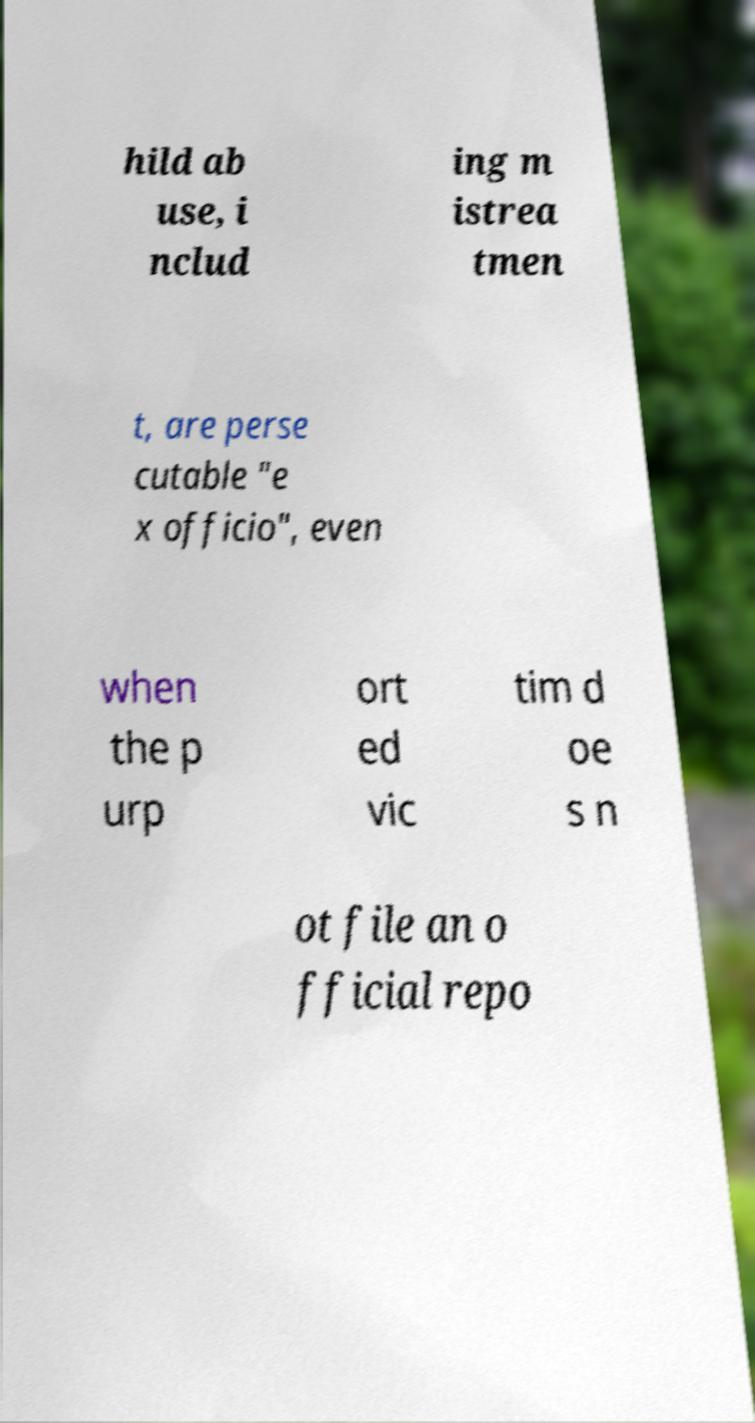For documentation purposes, I need the text within this image transcribed. Could you provide that? hild ab use, i nclud ing m istrea tmen t, are perse cutable "e x officio", even when the p urp ort ed vic tim d oe s n ot file an o fficial repo 